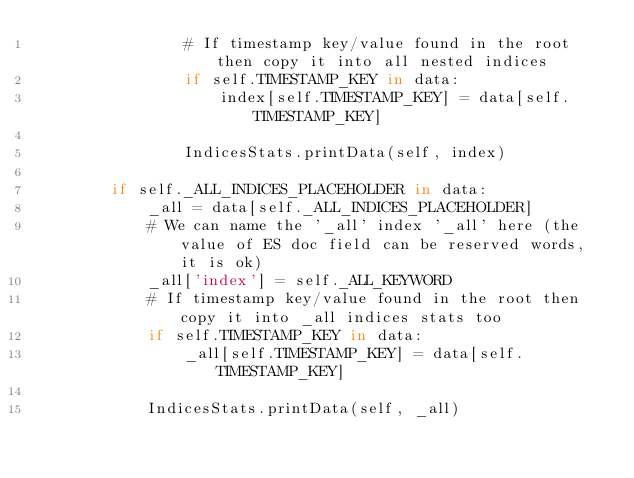Convert code to text. <code><loc_0><loc_0><loc_500><loc_500><_Python_>                # If timestamp key/value found in the root then copy it into all nested indices
                if self.TIMESTAMP_KEY in data:
                    index[self.TIMESTAMP_KEY] = data[self.TIMESTAMP_KEY]

                IndicesStats.printData(self, index)

        if self._ALL_INDICES_PLACEHOLDER in data:
            _all = data[self._ALL_INDICES_PLACEHOLDER]
            # We can name the '_all' index '_all' here (the value of ES doc field can be reserved words, it is ok)
            _all['index'] = self._ALL_KEYWORD
            # If timestamp key/value found in the root then copy it into _all indices stats too
            if self.TIMESTAMP_KEY in data:
                _all[self.TIMESTAMP_KEY] = data[self.TIMESTAMP_KEY]

            IndicesStats.printData(self, _all)
</code> 